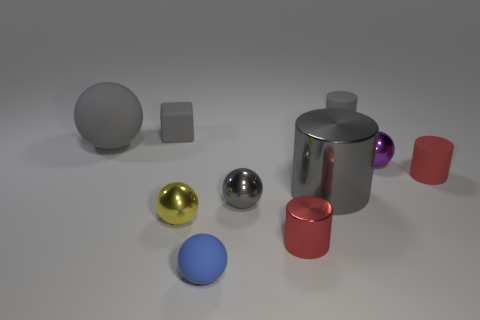Subtract all yellow balls. How many balls are left? 4 Subtract all tiny gray metallic spheres. How many spheres are left? 4 Subtract all brown cylinders. Subtract all blue spheres. How many cylinders are left? 4 Subtract all cylinders. How many objects are left? 6 Add 1 red rubber things. How many red rubber things exist? 2 Subtract 0 cyan cubes. How many objects are left? 10 Subtract all gray cylinders. Subtract all tiny objects. How many objects are left? 0 Add 3 large gray balls. How many large gray balls are left? 4 